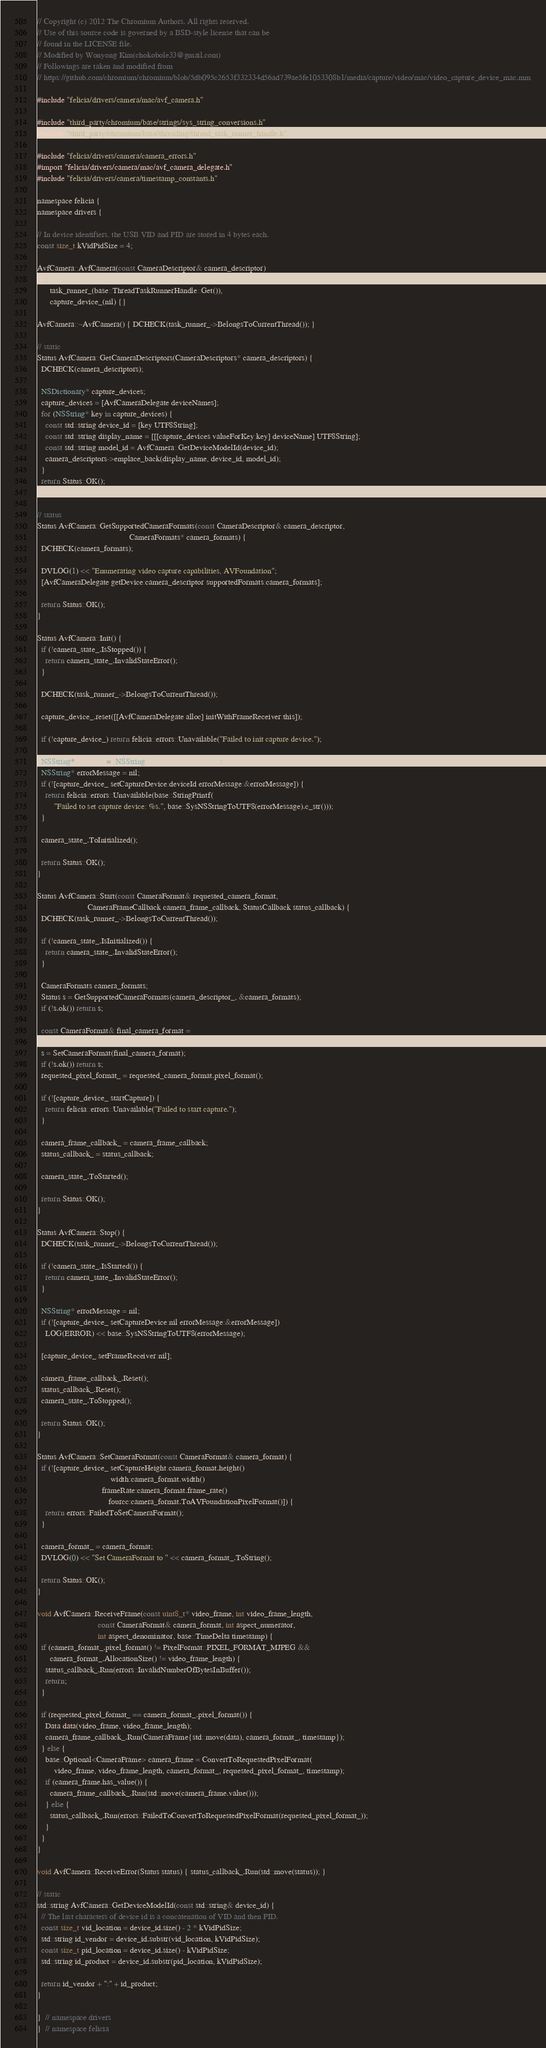Convert code to text. <code><loc_0><loc_0><loc_500><loc_500><_ObjectiveC_>// Copyright (c) 2012 The Chromium Authors. All rights reserved.
// Use of this source code is governed by a BSD-style license that can be
// found in the LICENSE file.
// Modified by Wonyong Kim(chokobole33@gmail.com)
// Followings are taken and modified from
// https://github.com/chromium/chromium/blob/5db095c2653f332334d56ad739ae5fe1053308b1/media/capture/video/mac/video_capture_device_mac.mm

#include "felicia/drivers/camera/mac/avf_camera.h"

#include "third_party/chromium/base/strings/sys_string_conversions.h"
#include "third_party/chromium/base/threading/thread_task_runner_handle.h"

#include "felicia/drivers/camera/camera_errors.h"
#import "felicia/drivers/camera/mac/avf_camera_delegate.h"
#include "felicia/drivers/camera/timestamp_constants.h"

namespace felicia {
namespace drivers {

// In device identifiers, the USB VID and PID are stored in 4 bytes each.
const size_t kVidPidSize = 4;

AvfCamera::AvfCamera(const CameraDescriptor& camera_descriptor)
    : CameraInterface(camera_descriptor),
      task_runner_(base::ThreadTaskRunnerHandle::Get()),
      capture_device_(nil) {}

AvfCamera::~AvfCamera() { DCHECK(task_runner_->BelongsToCurrentThread()); }

// static
Status AvfCamera::GetCameraDescriptors(CameraDescriptors* camera_descriptors) {
  DCHECK(camera_descriptors);

  NSDictionary* capture_devices;
  capture_devices = [AvfCameraDelegate deviceNames];
  for (NSString* key in capture_devices) {
    const std::string device_id = [key UTF8String];
    const std::string display_name = [[[capture_devices valueForKey:key] deviceName] UTF8String];
    const std::string model_id = AvfCamera::GetDeviceModelId(device_id);
    camera_descriptors->emplace_back(display_name, device_id, model_id);
  }
  return Status::OK();
}

// status
Status AvfCamera::GetSupportedCameraFormats(const CameraDescriptor& camera_descriptor,
                                            CameraFormats* camera_formats) {
  DCHECK(camera_formats);

  DVLOG(1) << "Enumerating video capture capabilities, AVFoundation";
  [AvfCameraDelegate getDevice:camera_descriptor supportedFormats:camera_formats];

  return Status::OK();
}

Status AvfCamera::Init() {
  if (!camera_state_.IsStopped()) {
    return camera_state_.InvalidStateError();
  }

  DCHECK(task_runner_->BelongsToCurrentThread());

  capture_device_.reset([[AvfCameraDelegate alloc] initWithFrameReceiver:this]);

  if (!capture_device_) return felicia::errors::Unavailable("Failed to init capture device.");

  NSString* deviceId = [NSString stringWithUTF8String:camera_descriptor_.device_id().c_str()];
  NSString* errorMessage = nil;
  if (![capture_device_ setCaptureDevice:deviceId errorMessage:&errorMessage]) {
    return felicia::errors::Unavailable(base::StringPrintf(
        "Failed to set capture device: %s.", base::SysNSStringToUTF8(errorMessage).c_str()));
  }

  camera_state_.ToInitialized();

  return Status::OK();
}

Status AvfCamera::Start(const CameraFormat& requested_camera_format,
                        CameraFrameCallback camera_frame_callback, StatusCallback status_callback) {
  DCHECK(task_runner_->BelongsToCurrentThread());

  if (!camera_state_.IsInitialized()) {
    return camera_state_.InvalidStateError();
  }

  CameraFormats camera_formats;
  Status s = GetSupportedCameraFormats(camera_descriptor_, &camera_formats);
  if (!s.ok()) return s;

  const CameraFormat& final_camera_format =
      GetBestMatchedCameraFormat(requested_camera_format, camera_formats);
  s = SetCameraFormat(final_camera_format);
  if (!s.ok()) return s;
  requested_pixel_format_ = requested_camera_format.pixel_format();

  if (![capture_device_ startCapture]) {
    return felicia::errors::Unavailable("Failed to start capture.");
  }

  camera_frame_callback_ = camera_frame_callback;
  status_callback_ = status_callback;

  camera_state_.ToStarted();

  return Status::OK();
}

Status AvfCamera::Stop() {
  DCHECK(task_runner_->BelongsToCurrentThread());

  if (!camera_state_.IsStarted()) {
    return camera_state_.InvalidStateError();
  }

  NSString* errorMessage = nil;
  if (![capture_device_ setCaptureDevice:nil errorMessage:&errorMessage])
    LOG(ERROR) << base::SysNSStringToUTF8(errorMessage);

  [capture_device_ setFrameReceiver:nil];

  camera_frame_callback_.Reset();
  status_callback_.Reset();
  camera_state_.ToStopped();

  return Status::OK();
}

Status AvfCamera::SetCameraFormat(const CameraFormat& camera_format) {
  if (![capture_device_ setCaptureHeight:camera_format.height()
                                   width:camera_format.width()
                               frameRate:camera_format.frame_rate()
                                  fourcc:camera_format.ToAVFoundationPixelFormat()]) {
    return errors::FailedToSetCameraFormat();
  }

  camera_format_ = camera_format;
  DVLOG(0) << "Set CameraFormat to " << camera_format_.ToString();

  return Status::OK();
}

void AvfCamera::ReceiveFrame(const uint8_t* video_frame, int video_frame_length,
                             const CameraFormat& camera_format, int aspect_numerator,
                             int aspect_denominator, base::TimeDelta timestamp) {
  if (camera_format_.pixel_format() != PixelFormat::PIXEL_FORMAT_MJPEG &&
      camera_format_.AllocationSize() != video_frame_length) {
    status_callback_.Run(errors::InvalidNumberOfBytesInBuffer());
    return;
  }

  if (requested_pixel_format_ == camera_format_.pixel_format()) {
    Data data(video_frame, video_frame_length);
    camera_frame_callback_.Run(CameraFrame{std::move(data), camera_format_, timestamp});
  } else {
    base::Optional<CameraFrame> camera_frame = ConvertToRequestedPixelFormat(
        video_frame, video_frame_length, camera_format_, requested_pixel_format_, timestamp);
    if (camera_frame.has_value()) {
      camera_frame_callback_.Run(std::move(camera_frame.value()));
    } else {
      status_callback_.Run(errors::FailedToConvertToRequestedPixelFormat(requested_pixel_format_));
    }
  }
}

void AvfCamera::ReceiveError(Status status) { status_callback_.Run(std::move(status)); }

// static
std::string AvfCamera::GetDeviceModelId(const std::string& device_id) {
  // The last characters of device id is a concatenation of VID and then PID.
  const size_t vid_location = device_id.size() - 2 * kVidPidSize;
  std::string id_vendor = device_id.substr(vid_location, kVidPidSize);
  const size_t pid_location = device_id.size() - kVidPidSize;
  std::string id_product = device_id.substr(pid_location, kVidPidSize);

  return id_vendor + ":" + id_product;
}

}  // namespace drivers
}  // namespace felicia</code> 